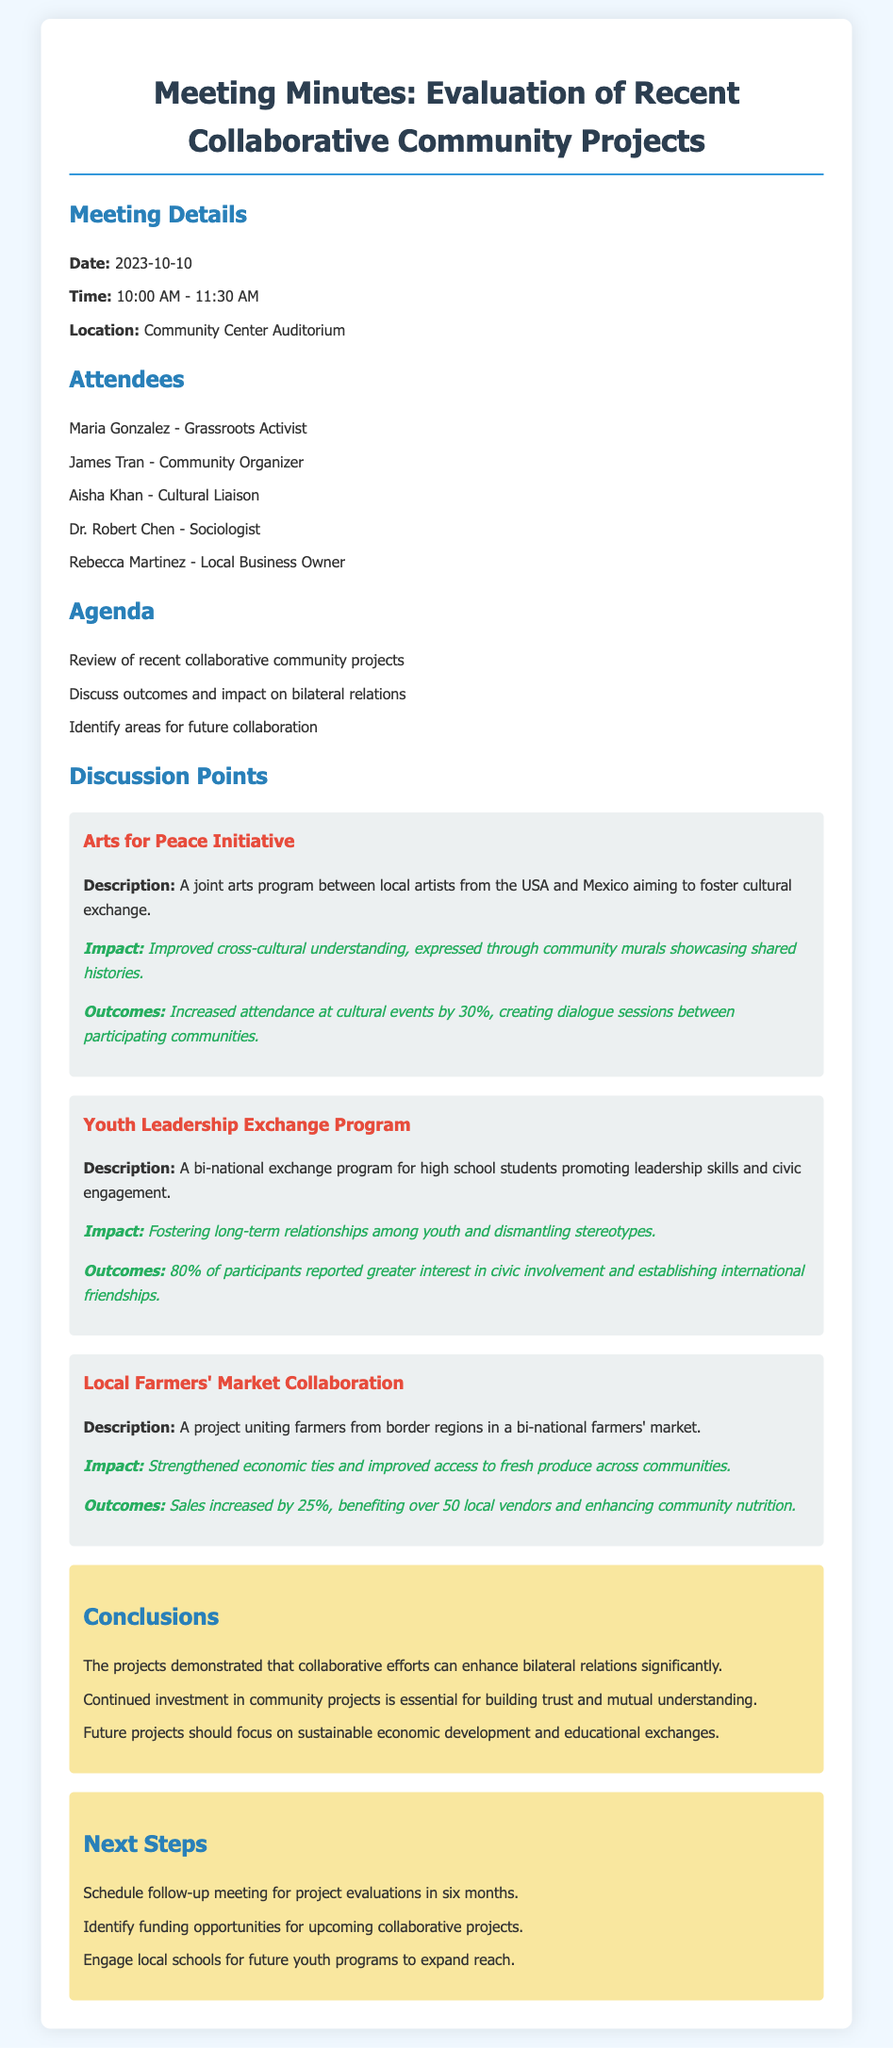what is the date of the meeting? The date of the meeting is explicitly mentioned in the document as 2023-10-10.
Answer: 2023-10-10 who is the grassroots activist present at the meeting? The document lists Maria Gonzalez as the grassroots activist in attendance.
Answer: Maria Gonzalez how many attendees were there? The document provides a list of attendees, which totals five individuals.
Answer: 5 what was the percentage increase in attendance at cultural events due to the Arts for Peace Initiative? The document states that attendance increased by 30% as a result of the initiative.
Answer: 30% what should future projects focus on according to the conclusions? The conclusions suggest that future projects should emphasize sustainable economic development and educational exchanges.
Answer: sustainable economic development and educational exchanges how will funding opportunities be handled according to the next steps? The next steps include identifying funding opportunities for upcoming collaborative projects as outlined in the document.
Answer: identifying funding opportunities what is the name of the collaboration project that involves local farmers? The document mentions the Local Farmers' Market Collaboration as the project involving farmers from border regions.
Answer: Local Farmers' Market Collaboration what is the impact of the Youth Leadership Exchange Program? The document notes that the program fosters long-term relationships among youth and dismantles stereotypes.
Answer: fostering long-term relationships among youth and dismantling stereotypes 